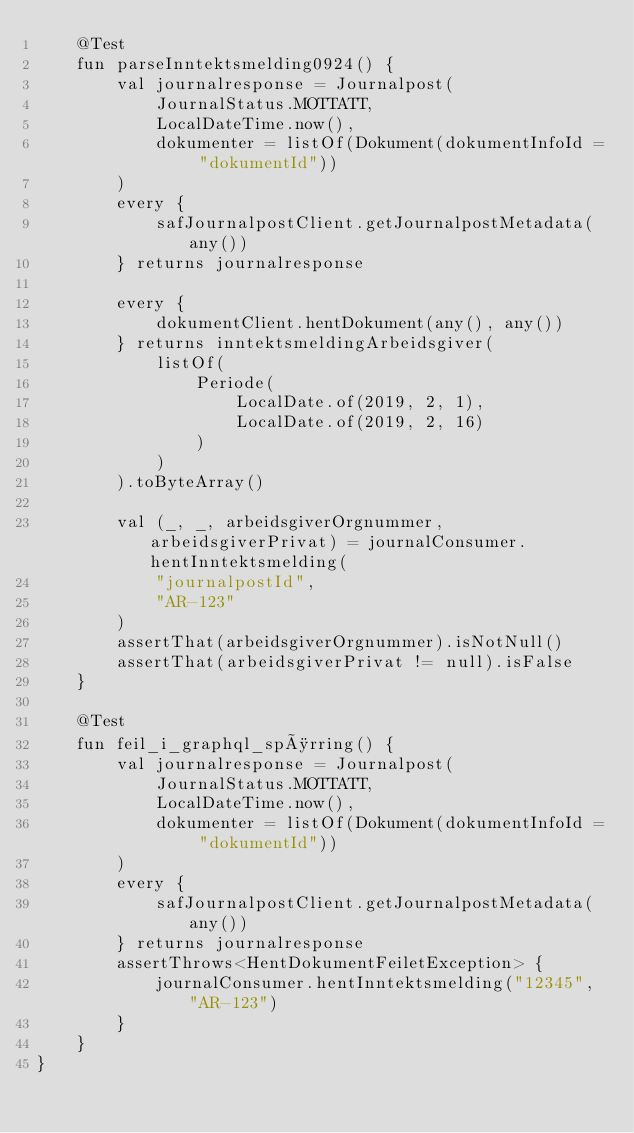<code> <loc_0><loc_0><loc_500><loc_500><_Kotlin_>    @Test
    fun parseInntektsmelding0924() {
        val journalresponse = Journalpost(
            JournalStatus.MOTTATT,
            LocalDateTime.now(),
            dokumenter = listOf(Dokument(dokumentInfoId = "dokumentId"))
        )
        every {
            safJournalpostClient.getJournalpostMetadata(any())
        } returns journalresponse

        every {
            dokumentClient.hentDokument(any(), any())
        } returns inntektsmeldingArbeidsgiver(
            listOf(
                Periode(
                    LocalDate.of(2019, 2, 1),
                    LocalDate.of(2019, 2, 16)
                )
            )
        ).toByteArray()

        val (_, _, arbeidsgiverOrgnummer, arbeidsgiverPrivat) = journalConsumer.hentInntektsmelding(
            "journalpostId",
            "AR-123"
        )
        assertThat(arbeidsgiverOrgnummer).isNotNull()
        assertThat(arbeidsgiverPrivat != null).isFalse
    }

    @Test
    fun feil_i_graphql_spørring() {
        val journalresponse = Journalpost(
            JournalStatus.MOTTATT,
            LocalDateTime.now(),
            dokumenter = listOf(Dokument(dokumentInfoId = "dokumentId"))
        )
        every {
            safJournalpostClient.getJournalpostMetadata(any())
        } returns journalresponse
        assertThrows<HentDokumentFeiletException> {
            journalConsumer.hentInntektsmelding("12345", "AR-123")
        }
    }
}
</code> 